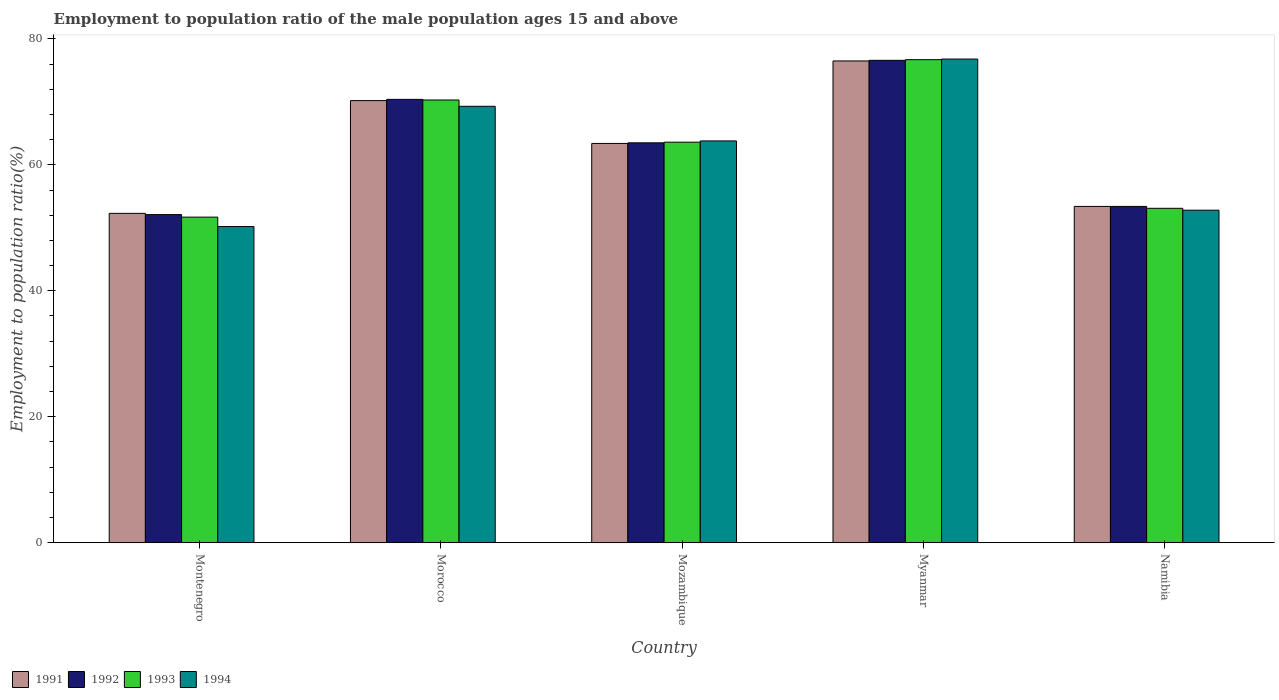How many bars are there on the 1st tick from the left?
Your answer should be compact. 4. What is the label of the 2nd group of bars from the left?
Offer a terse response. Morocco. In how many cases, is the number of bars for a given country not equal to the number of legend labels?
Provide a succinct answer. 0. What is the employment to population ratio in 1991 in Montenegro?
Your response must be concise. 52.3. Across all countries, what is the maximum employment to population ratio in 1994?
Keep it short and to the point. 76.8. Across all countries, what is the minimum employment to population ratio in 1992?
Provide a succinct answer. 52.1. In which country was the employment to population ratio in 1994 maximum?
Keep it short and to the point. Myanmar. In which country was the employment to population ratio in 1993 minimum?
Make the answer very short. Montenegro. What is the total employment to population ratio in 1993 in the graph?
Offer a very short reply. 315.4. What is the difference between the employment to population ratio in 1992 in Morocco and that in Mozambique?
Ensure brevity in your answer.  6.9. What is the difference between the employment to population ratio in 1994 in Myanmar and the employment to population ratio in 1991 in Namibia?
Offer a terse response. 23.4. What is the average employment to population ratio in 1991 per country?
Your response must be concise. 63.16. What is the difference between the employment to population ratio of/in 1993 and employment to population ratio of/in 1992 in Mozambique?
Make the answer very short. 0.1. What is the ratio of the employment to population ratio in 1992 in Mozambique to that in Namibia?
Ensure brevity in your answer.  1.19. Is the employment to population ratio in 1992 in Mozambique less than that in Namibia?
Your answer should be very brief. No. What is the difference between the highest and the second highest employment to population ratio in 1991?
Your answer should be very brief. 6.3. What is the difference between the highest and the lowest employment to population ratio in 1994?
Give a very brief answer. 26.6. Is the sum of the employment to population ratio in 1994 in Montenegro and Morocco greater than the maximum employment to population ratio in 1991 across all countries?
Your answer should be very brief. Yes. Is it the case that in every country, the sum of the employment to population ratio in 1994 and employment to population ratio in 1992 is greater than the sum of employment to population ratio in 1991 and employment to population ratio in 1993?
Keep it short and to the point. No. What does the 1st bar from the left in Namibia represents?
Offer a very short reply. 1991. Is it the case that in every country, the sum of the employment to population ratio in 1994 and employment to population ratio in 1992 is greater than the employment to population ratio in 1991?
Keep it short and to the point. Yes. Does the graph contain grids?
Your answer should be very brief. No. How many legend labels are there?
Make the answer very short. 4. How are the legend labels stacked?
Ensure brevity in your answer.  Horizontal. What is the title of the graph?
Offer a very short reply. Employment to population ratio of the male population ages 15 and above. Does "1962" appear as one of the legend labels in the graph?
Your answer should be compact. No. What is the label or title of the X-axis?
Keep it short and to the point. Country. What is the label or title of the Y-axis?
Provide a short and direct response. Employment to population ratio(%). What is the Employment to population ratio(%) in 1991 in Montenegro?
Keep it short and to the point. 52.3. What is the Employment to population ratio(%) in 1992 in Montenegro?
Provide a succinct answer. 52.1. What is the Employment to population ratio(%) of 1993 in Montenegro?
Give a very brief answer. 51.7. What is the Employment to population ratio(%) of 1994 in Montenegro?
Provide a short and direct response. 50.2. What is the Employment to population ratio(%) of 1991 in Morocco?
Provide a succinct answer. 70.2. What is the Employment to population ratio(%) of 1992 in Morocco?
Make the answer very short. 70.4. What is the Employment to population ratio(%) of 1993 in Morocco?
Ensure brevity in your answer.  70.3. What is the Employment to population ratio(%) in 1994 in Morocco?
Your answer should be very brief. 69.3. What is the Employment to population ratio(%) in 1991 in Mozambique?
Provide a short and direct response. 63.4. What is the Employment to population ratio(%) of 1992 in Mozambique?
Give a very brief answer. 63.5. What is the Employment to population ratio(%) in 1993 in Mozambique?
Provide a short and direct response. 63.6. What is the Employment to population ratio(%) in 1994 in Mozambique?
Your answer should be compact. 63.8. What is the Employment to population ratio(%) in 1991 in Myanmar?
Provide a succinct answer. 76.5. What is the Employment to population ratio(%) in 1992 in Myanmar?
Ensure brevity in your answer.  76.6. What is the Employment to population ratio(%) of 1993 in Myanmar?
Offer a very short reply. 76.7. What is the Employment to population ratio(%) in 1994 in Myanmar?
Provide a short and direct response. 76.8. What is the Employment to population ratio(%) of 1991 in Namibia?
Ensure brevity in your answer.  53.4. What is the Employment to population ratio(%) in 1992 in Namibia?
Provide a short and direct response. 53.4. What is the Employment to population ratio(%) in 1993 in Namibia?
Your answer should be very brief. 53.1. What is the Employment to population ratio(%) in 1994 in Namibia?
Offer a terse response. 52.8. Across all countries, what is the maximum Employment to population ratio(%) in 1991?
Your answer should be compact. 76.5. Across all countries, what is the maximum Employment to population ratio(%) of 1992?
Offer a terse response. 76.6. Across all countries, what is the maximum Employment to population ratio(%) in 1993?
Your answer should be very brief. 76.7. Across all countries, what is the maximum Employment to population ratio(%) in 1994?
Your answer should be compact. 76.8. Across all countries, what is the minimum Employment to population ratio(%) of 1991?
Give a very brief answer. 52.3. Across all countries, what is the minimum Employment to population ratio(%) in 1992?
Offer a very short reply. 52.1. Across all countries, what is the minimum Employment to population ratio(%) in 1993?
Offer a terse response. 51.7. Across all countries, what is the minimum Employment to population ratio(%) of 1994?
Provide a short and direct response. 50.2. What is the total Employment to population ratio(%) of 1991 in the graph?
Make the answer very short. 315.8. What is the total Employment to population ratio(%) in 1992 in the graph?
Provide a succinct answer. 316. What is the total Employment to population ratio(%) of 1993 in the graph?
Provide a short and direct response. 315.4. What is the total Employment to population ratio(%) of 1994 in the graph?
Ensure brevity in your answer.  312.9. What is the difference between the Employment to population ratio(%) in 1991 in Montenegro and that in Morocco?
Your answer should be compact. -17.9. What is the difference between the Employment to population ratio(%) in 1992 in Montenegro and that in Morocco?
Give a very brief answer. -18.3. What is the difference between the Employment to population ratio(%) in 1993 in Montenegro and that in Morocco?
Offer a terse response. -18.6. What is the difference between the Employment to population ratio(%) of 1994 in Montenegro and that in Morocco?
Your answer should be compact. -19.1. What is the difference between the Employment to population ratio(%) in 1992 in Montenegro and that in Mozambique?
Your answer should be compact. -11.4. What is the difference between the Employment to population ratio(%) in 1991 in Montenegro and that in Myanmar?
Your answer should be very brief. -24.2. What is the difference between the Employment to population ratio(%) of 1992 in Montenegro and that in Myanmar?
Give a very brief answer. -24.5. What is the difference between the Employment to population ratio(%) in 1994 in Montenegro and that in Myanmar?
Give a very brief answer. -26.6. What is the difference between the Employment to population ratio(%) in 1991 in Morocco and that in Mozambique?
Give a very brief answer. 6.8. What is the difference between the Employment to population ratio(%) of 1992 in Morocco and that in Mozambique?
Provide a succinct answer. 6.9. What is the difference between the Employment to population ratio(%) of 1991 in Morocco and that in Myanmar?
Ensure brevity in your answer.  -6.3. What is the difference between the Employment to population ratio(%) in 1992 in Morocco and that in Myanmar?
Your answer should be compact. -6.2. What is the difference between the Employment to population ratio(%) of 1993 in Morocco and that in Myanmar?
Offer a terse response. -6.4. What is the difference between the Employment to population ratio(%) in 1994 in Morocco and that in Myanmar?
Give a very brief answer. -7.5. What is the difference between the Employment to population ratio(%) of 1991 in Morocco and that in Namibia?
Keep it short and to the point. 16.8. What is the difference between the Employment to population ratio(%) in 1992 in Morocco and that in Namibia?
Provide a succinct answer. 17. What is the difference between the Employment to population ratio(%) in 1994 in Morocco and that in Namibia?
Offer a very short reply. 16.5. What is the difference between the Employment to population ratio(%) in 1992 in Mozambique and that in Myanmar?
Give a very brief answer. -13.1. What is the difference between the Employment to population ratio(%) in 1991 in Mozambique and that in Namibia?
Your answer should be compact. 10. What is the difference between the Employment to population ratio(%) of 1992 in Mozambique and that in Namibia?
Provide a short and direct response. 10.1. What is the difference between the Employment to population ratio(%) in 1994 in Mozambique and that in Namibia?
Your answer should be very brief. 11. What is the difference between the Employment to population ratio(%) of 1991 in Myanmar and that in Namibia?
Make the answer very short. 23.1. What is the difference between the Employment to population ratio(%) of 1992 in Myanmar and that in Namibia?
Make the answer very short. 23.2. What is the difference between the Employment to population ratio(%) in 1993 in Myanmar and that in Namibia?
Your response must be concise. 23.6. What is the difference between the Employment to population ratio(%) of 1994 in Myanmar and that in Namibia?
Your answer should be compact. 24. What is the difference between the Employment to population ratio(%) in 1991 in Montenegro and the Employment to population ratio(%) in 1992 in Morocco?
Provide a succinct answer. -18.1. What is the difference between the Employment to population ratio(%) of 1991 in Montenegro and the Employment to population ratio(%) of 1994 in Morocco?
Provide a short and direct response. -17. What is the difference between the Employment to population ratio(%) of 1992 in Montenegro and the Employment to population ratio(%) of 1993 in Morocco?
Offer a terse response. -18.2. What is the difference between the Employment to population ratio(%) of 1992 in Montenegro and the Employment to population ratio(%) of 1994 in Morocco?
Keep it short and to the point. -17.2. What is the difference between the Employment to population ratio(%) in 1993 in Montenegro and the Employment to population ratio(%) in 1994 in Morocco?
Provide a short and direct response. -17.6. What is the difference between the Employment to population ratio(%) of 1991 in Montenegro and the Employment to population ratio(%) of 1993 in Mozambique?
Your answer should be very brief. -11.3. What is the difference between the Employment to population ratio(%) in 1992 in Montenegro and the Employment to population ratio(%) in 1993 in Mozambique?
Keep it short and to the point. -11.5. What is the difference between the Employment to population ratio(%) in 1993 in Montenegro and the Employment to population ratio(%) in 1994 in Mozambique?
Give a very brief answer. -12.1. What is the difference between the Employment to population ratio(%) of 1991 in Montenegro and the Employment to population ratio(%) of 1992 in Myanmar?
Give a very brief answer. -24.3. What is the difference between the Employment to population ratio(%) in 1991 in Montenegro and the Employment to population ratio(%) in 1993 in Myanmar?
Your answer should be compact. -24.4. What is the difference between the Employment to population ratio(%) of 1991 in Montenegro and the Employment to population ratio(%) of 1994 in Myanmar?
Offer a terse response. -24.5. What is the difference between the Employment to population ratio(%) of 1992 in Montenegro and the Employment to population ratio(%) of 1993 in Myanmar?
Make the answer very short. -24.6. What is the difference between the Employment to population ratio(%) of 1992 in Montenegro and the Employment to population ratio(%) of 1994 in Myanmar?
Keep it short and to the point. -24.7. What is the difference between the Employment to population ratio(%) in 1993 in Montenegro and the Employment to population ratio(%) in 1994 in Myanmar?
Offer a terse response. -25.1. What is the difference between the Employment to population ratio(%) in 1991 in Montenegro and the Employment to population ratio(%) in 1993 in Namibia?
Provide a succinct answer. -0.8. What is the difference between the Employment to population ratio(%) in 1991 in Montenegro and the Employment to population ratio(%) in 1994 in Namibia?
Offer a very short reply. -0.5. What is the difference between the Employment to population ratio(%) in 1992 in Montenegro and the Employment to population ratio(%) in 1993 in Namibia?
Your answer should be compact. -1. What is the difference between the Employment to population ratio(%) in 1992 in Montenegro and the Employment to population ratio(%) in 1994 in Namibia?
Keep it short and to the point. -0.7. What is the difference between the Employment to population ratio(%) in 1991 in Morocco and the Employment to population ratio(%) in 1992 in Mozambique?
Offer a terse response. 6.7. What is the difference between the Employment to population ratio(%) in 1992 in Morocco and the Employment to population ratio(%) in 1993 in Mozambique?
Offer a terse response. 6.8. What is the difference between the Employment to population ratio(%) of 1992 in Morocco and the Employment to population ratio(%) of 1994 in Mozambique?
Your response must be concise. 6.6. What is the difference between the Employment to population ratio(%) of 1993 in Morocco and the Employment to population ratio(%) of 1994 in Mozambique?
Your response must be concise. 6.5. What is the difference between the Employment to population ratio(%) of 1991 in Morocco and the Employment to population ratio(%) of 1992 in Myanmar?
Make the answer very short. -6.4. What is the difference between the Employment to population ratio(%) of 1991 in Morocco and the Employment to population ratio(%) of 1993 in Myanmar?
Your response must be concise. -6.5. What is the difference between the Employment to population ratio(%) of 1991 in Morocco and the Employment to population ratio(%) of 1994 in Myanmar?
Ensure brevity in your answer.  -6.6. What is the difference between the Employment to population ratio(%) in 1992 in Morocco and the Employment to population ratio(%) in 1993 in Namibia?
Make the answer very short. 17.3. What is the difference between the Employment to population ratio(%) in 1993 in Morocco and the Employment to population ratio(%) in 1994 in Namibia?
Your answer should be compact. 17.5. What is the difference between the Employment to population ratio(%) of 1991 in Mozambique and the Employment to population ratio(%) of 1992 in Myanmar?
Give a very brief answer. -13.2. What is the difference between the Employment to population ratio(%) of 1991 in Mozambique and the Employment to population ratio(%) of 1993 in Myanmar?
Offer a terse response. -13.3. What is the difference between the Employment to population ratio(%) of 1991 in Mozambique and the Employment to population ratio(%) of 1994 in Myanmar?
Make the answer very short. -13.4. What is the difference between the Employment to population ratio(%) of 1992 in Mozambique and the Employment to population ratio(%) of 1993 in Myanmar?
Keep it short and to the point. -13.2. What is the difference between the Employment to population ratio(%) of 1993 in Mozambique and the Employment to population ratio(%) of 1994 in Myanmar?
Provide a short and direct response. -13.2. What is the difference between the Employment to population ratio(%) in 1991 in Mozambique and the Employment to population ratio(%) in 1994 in Namibia?
Give a very brief answer. 10.6. What is the difference between the Employment to population ratio(%) in 1992 in Mozambique and the Employment to population ratio(%) in 1993 in Namibia?
Your response must be concise. 10.4. What is the difference between the Employment to population ratio(%) of 1991 in Myanmar and the Employment to population ratio(%) of 1992 in Namibia?
Keep it short and to the point. 23.1. What is the difference between the Employment to population ratio(%) in 1991 in Myanmar and the Employment to population ratio(%) in 1993 in Namibia?
Your answer should be very brief. 23.4. What is the difference between the Employment to population ratio(%) of 1991 in Myanmar and the Employment to population ratio(%) of 1994 in Namibia?
Provide a succinct answer. 23.7. What is the difference between the Employment to population ratio(%) of 1992 in Myanmar and the Employment to population ratio(%) of 1994 in Namibia?
Offer a terse response. 23.8. What is the difference between the Employment to population ratio(%) in 1993 in Myanmar and the Employment to population ratio(%) in 1994 in Namibia?
Your response must be concise. 23.9. What is the average Employment to population ratio(%) in 1991 per country?
Offer a terse response. 63.16. What is the average Employment to population ratio(%) of 1992 per country?
Your response must be concise. 63.2. What is the average Employment to population ratio(%) in 1993 per country?
Provide a short and direct response. 63.08. What is the average Employment to population ratio(%) of 1994 per country?
Your answer should be very brief. 62.58. What is the difference between the Employment to population ratio(%) of 1991 and Employment to population ratio(%) of 1993 in Montenegro?
Provide a succinct answer. 0.6. What is the difference between the Employment to population ratio(%) of 1992 and Employment to population ratio(%) of 1993 in Montenegro?
Offer a terse response. 0.4. What is the difference between the Employment to population ratio(%) in 1993 and Employment to population ratio(%) in 1994 in Montenegro?
Make the answer very short. 1.5. What is the difference between the Employment to population ratio(%) of 1991 and Employment to population ratio(%) of 1992 in Morocco?
Ensure brevity in your answer.  -0.2. What is the difference between the Employment to population ratio(%) in 1991 and Employment to population ratio(%) in 1993 in Morocco?
Offer a very short reply. -0.1. What is the difference between the Employment to population ratio(%) of 1991 and Employment to population ratio(%) of 1992 in Mozambique?
Give a very brief answer. -0.1. What is the difference between the Employment to population ratio(%) in 1992 and Employment to population ratio(%) in 1994 in Mozambique?
Offer a very short reply. -0.3. What is the difference between the Employment to population ratio(%) of 1993 and Employment to population ratio(%) of 1994 in Mozambique?
Offer a very short reply. -0.2. What is the difference between the Employment to population ratio(%) of 1991 and Employment to population ratio(%) of 1994 in Myanmar?
Provide a succinct answer. -0.3. What is the difference between the Employment to population ratio(%) in 1992 and Employment to population ratio(%) in 1993 in Myanmar?
Your answer should be very brief. -0.1. What is the difference between the Employment to population ratio(%) of 1992 and Employment to population ratio(%) of 1994 in Myanmar?
Provide a succinct answer. -0.2. What is the difference between the Employment to population ratio(%) of 1993 and Employment to population ratio(%) of 1994 in Myanmar?
Offer a terse response. -0.1. What is the difference between the Employment to population ratio(%) of 1991 and Employment to population ratio(%) of 1994 in Namibia?
Offer a very short reply. 0.6. What is the difference between the Employment to population ratio(%) of 1992 and Employment to population ratio(%) of 1993 in Namibia?
Your answer should be compact. 0.3. What is the difference between the Employment to population ratio(%) of 1993 and Employment to population ratio(%) of 1994 in Namibia?
Your answer should be compact. 0.3. What is the ratio of the Employment to population ratio(%) in 1991 in Montenegro to that in Morocco?
Ensure brevity in your answer.  0.74. What is the ratio of the Employment to population ratio(%) in 1992 in Montenegro to that in Morocco?
Provide a succinct answer. 0.74. What is the ratio of the Employment to population ratio(%) in 1993 in Montenegro to that in Morocco?
Provide a succinct answer. 0.74. What is the ratio of the Employment to population ratio(%) of 1994 in Montenegro to that in Morocco?
Offer a very short reply. 0.72. What is the ratio of the Employment to population ratio(%) in 1991 in Montenegro to that in Mozambique?
Provide a short and direct response. 0.82. What is the ratio of the Employment to population ratio(%) of 1992 in Montenegro to that in Mozambique?
Ensure brevity in your answer.  0.82. What is the ratio of the Employment to population ratio(%) of 1993 in Montenegro to that in Mozambique?
Your response must be concise. 0.81. What is the ratio of the Employment to population ratio(%) in 1994 in Montenegro to that in Mozambique?
Make the answer very short. 0.79. What is the ratio of the Employment to population ratio(%) of 1991 in Montenegro to that in Myanmar?
Your response must be concise. 0.68. What is the ratio of the Employment to population ratio(%) of 1992 in Montenegro to that in Myanmar?
Provide a short and direct response. 0.68. What is the ratio of the Employment to population ratio(%) in 1993 in Montenegro to that in Myanmar?
Ensure brevity in your answer.  0.67. What is the ratio of the Employment to population ratio(%) in 1994 in Montenegro to that in Myanmar?
Keep it short and to the point. 0.65. What is the ratio of the Employment to population ratio(%) of 1991 in Montenegro to that in Namibia?
Make the answer very short. 0.98. What is the ratio of the Employment to population ratio(%) of 1992 in Montenegro to that in Namibia?
Give a very brief answer. 0.98. What is the ratio of the Employment to population ratio(%) of 1993 in Montenegro to that in Namibia?
Offer a very short reply. 0.97. What is the ratio of the Employment to population ratio(%) of 1994 in Montenegro to that in Namibia?
Keep it short and to the point. 0.95. What is the ratio of the Employment to population ratio(%) of 1991 in Morocco to that in Mozambique?
Provide a short and direct response. 1.11. What is the ratio of the Employment to population ratio(%) in 1992 in Morocco to that in Mozambique?
Ensure brevity in your answer.  1.11. What is the ratio of the Employment to population ratio(%) in 1993 in Morocco to that in Mozambique?
Offer a terse response. 1.11. What is the ratio of the Employment to population ratio(%) in 1994 in Morocco to that in Mozambique?
Provide a short and direct response. 1.09. What is the ratio of the Employment to population ratio(%) in 1991 in Morocco to that in Myanmar?
Make the answer very short. 0.92. What is the ratio of the Employment to population ratio(%) of 1992 in Morocco to that in Myanmar?
Ensure brevity in your answer.  0.92. What is the ratio of the Employment to population ratio(%) of 1993 in Morocco to that in Myanmar?
Keep it short and to the point. 0.92. What is the ratio of the Employment to population ratio(%) of 1994 in Morocco to that in Myanmar?
Your answer should be compact. 0.9. What is the ratio of the Employment to population ratio(%) in 1991 in Morocco to that in Namibia?
Offer a very short reply. 1.31. What is the ratio of the Employment to population ratio(%) of 1992 in Morocco to that in Namibia?
Your answer should be compact. 1.32. What is the ratio of the Employment to population ratio(%) of 1993 in Morocco to that in Namibia?
Provide a succinct answer. 1.32. What is the ratio of the Employment to population ratio(%) in 1994 in Morocco to that in Namibia?
Offer a terse response. 1.31. What is the ratio of the Employment to population ratio(%) in 1991 in Mozambique to that in Myanmar?
Provide a succinct answer. 0.83. What is the ratio of the Employment to population ratio(%) of 1992 in Mozambique to that in Myanmar?
Make the answer very short. 0.83. What is the ratio of the Employment to population ratio(%) in 1993 in Mozambique to that in Myanmar?
Make the answer very short. 0.83. What is the ratio of the Employment to population ratio(%) in 1994 in Mozambique to that in Myanmar?
Give a very brief answer. 0.83. What is the ratio of the Employment to population ratio(%) in 1991 in Mozambique to that in Namibia?
Offer a very short reply. 1.19. What is the ratio of the Employment to population ratio(%) in 1992 in Mozambique to that in Namibia?
Ensure brevity in your answer.  1.19. What is the ratio of the Employment to population ratio(%) of 1993 in Mozambique to that in Namibia?
Your answer should be very brief. 1.2. What is the ratio of the Employment to population ratio(%) of 1994 in Mozambique to that in Namibia?
Keep it short and to the point. 1.21. What is the ratio of the Employment to population ratio(%) in 1991 in Myanmar to that in Namibia?
Offer a terse response. 1.43. What is the ratio of the Employment to population ratio(%) of 1992 in Myanmar to that in Namibia?
Offer a very short reply. 1.43. What is the ratio of the Employment to population ratio(%) in 1993 in Myanmar to that in Namibia?
Ensure brevity in your answer.  1.44. What is the ratio of the Employment to population ratio(%) of 1994 in Myanmar to that in Namibia?
Give a very brief answer. 1.45. What is the difference between the highest and the second highest Employment to population ratio(%) in 1991?
Your answer should be very brief. 6.3. What is the difference between the highest and the second highest Employment to population ratio(%) of 1993?
Make the answer very short. 6.4. What is the difference between the highest and the second highest Employment to population ratio(%) of 1994?
Offer a terse response. 7.5. What is the difference between the highest and the lowest Employment to population ratio(%) in 1991?
Give a very brief answer. 24.2. What is the difference between the highest and the lowest Employment to population ratio(%) of 1994?
Make the answer very short. 26.6. 